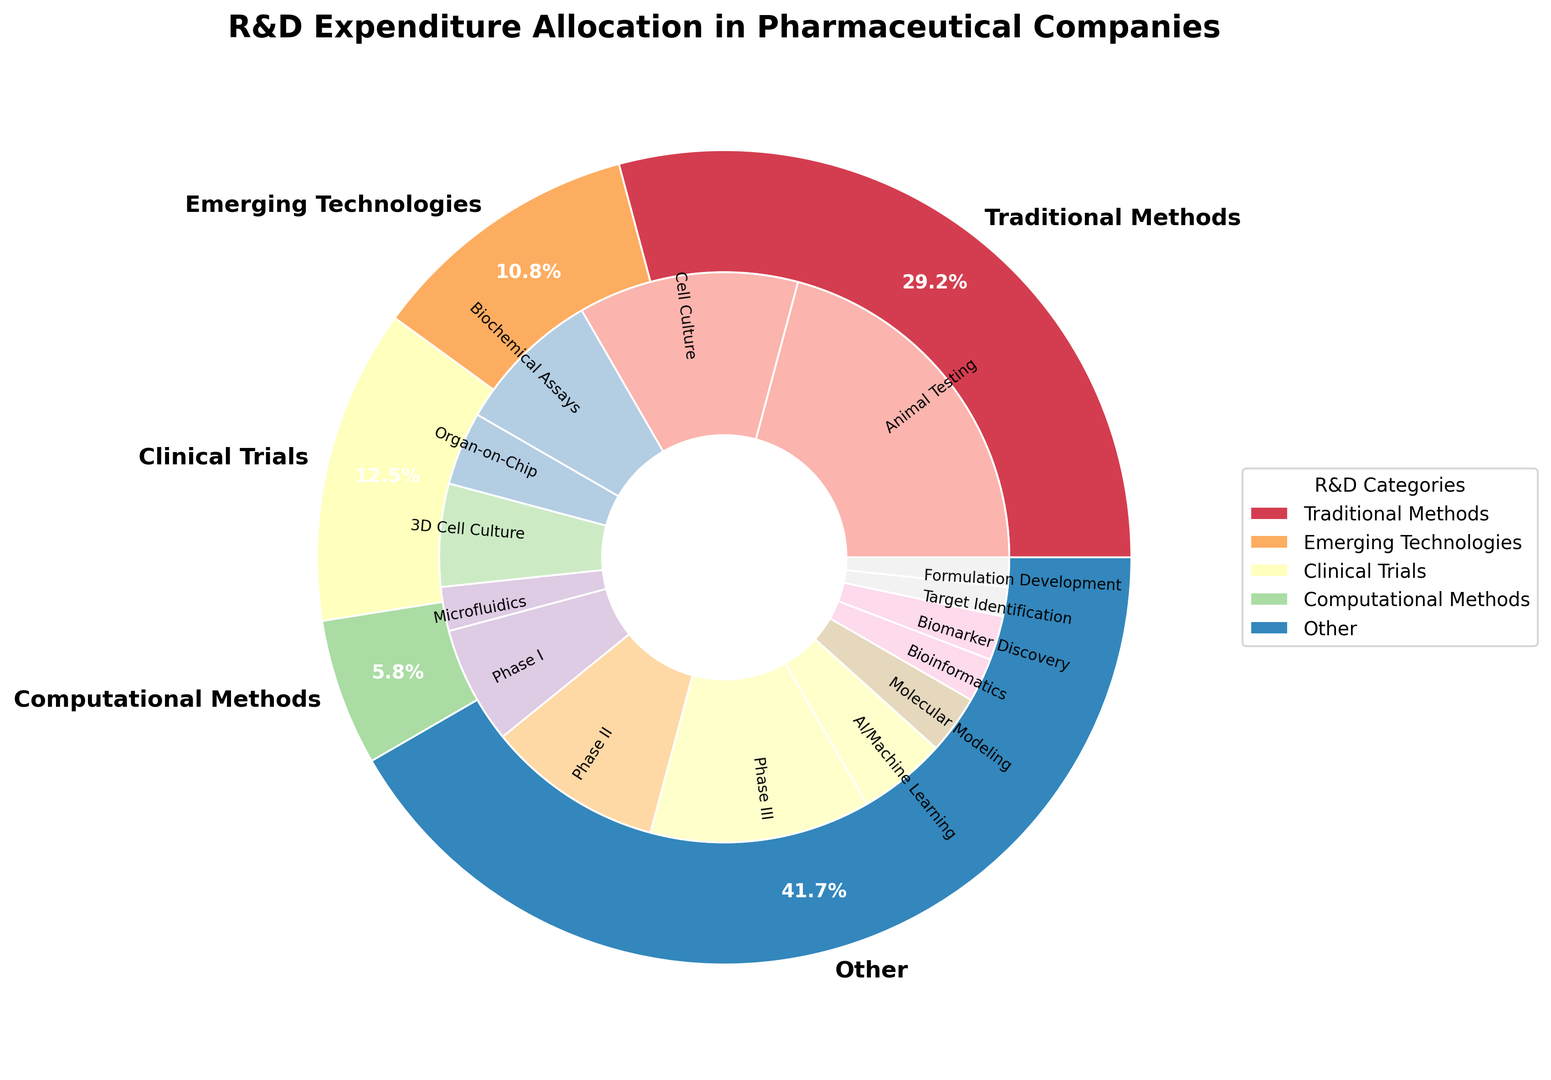Which subcategory has the highest percentage in R&D expenditure allocation? The largest wedge in the inner ring represents Animal Testing under Traditional Methods. By observing the figure, Animal Testing has the highest single subcategory percentage at 25%.
Answer: Animal Testing How much more is spent on Emerging Technologies compared to Computational Methods? Sum the percentages for Emerging Technologies (5% + 7% + 3% = 15%) and for Computational Methods (6% + 4% + 3% = 13%). The difference is 15% - 13% = 2%.
Answer: 2% Which has a higher allocation: Phase II clinical trials or AI/Machine Learning? Compare the percentages directly from the chart: Phase II clinical trials have 12%, and AI/Machine Learning has 6%. Since 12% is greater than 6%, Phase II clinical trials have a higher allocation.
Answer: Phase II clinical trials What is the combined percentage of all methods under Traditional Methods? Sum the percentages for Animal Testing, Cell Culture, and Biochemical Assays: 25% + 15% + 10% = 50%.
Answer: 50% Among the subcategories under Other, which one has the lowest allocation? Compare the segments within the Other category. Biomarker Discovery has 3%, Target Identification has 2%, and Formulation Development also has 2%. Since 2% is the lowest, both Target Identification and Formulation Development have the lowest allocation.
Answer: Target Identification, Formulation Development What is the proportion of the total R&D expenditure allocated to Clinical Trials? Sum the percentages for Phase I, Phase II, and Phase III trials: 8% + 12% + 15% = 35%.
Answer: 35% Between Organ-on-Chip and 3D Cell Culture, which has a smaller percentage of the R&D budget? Compare the individual percentages: Organ-on-Chip has 5% and 3D Cell Culture has 7%. Therefore, Organ-on-Chip has a smaller percentage.
Answer: Organ-on-Chip How does the allocation for Biochemical Assays compare to that for Biomarker Discovery? From the chart, Biochemical Assays have 10% and Biomarker Discovery has 3%. As 10% is greater than 3%, Biochemical Assays have a higher allocation.
Answer: Biochemical Assays Which subcategory under Traditional Methods has the lowest allocation? Compare the subcategories under Traditional Methods: Animal Testing (25%), Cell Culture (15%), and Biochemical Assays (10%). Biochemical Assays have the lowest allocation.
Answer: Biochemical Assays 